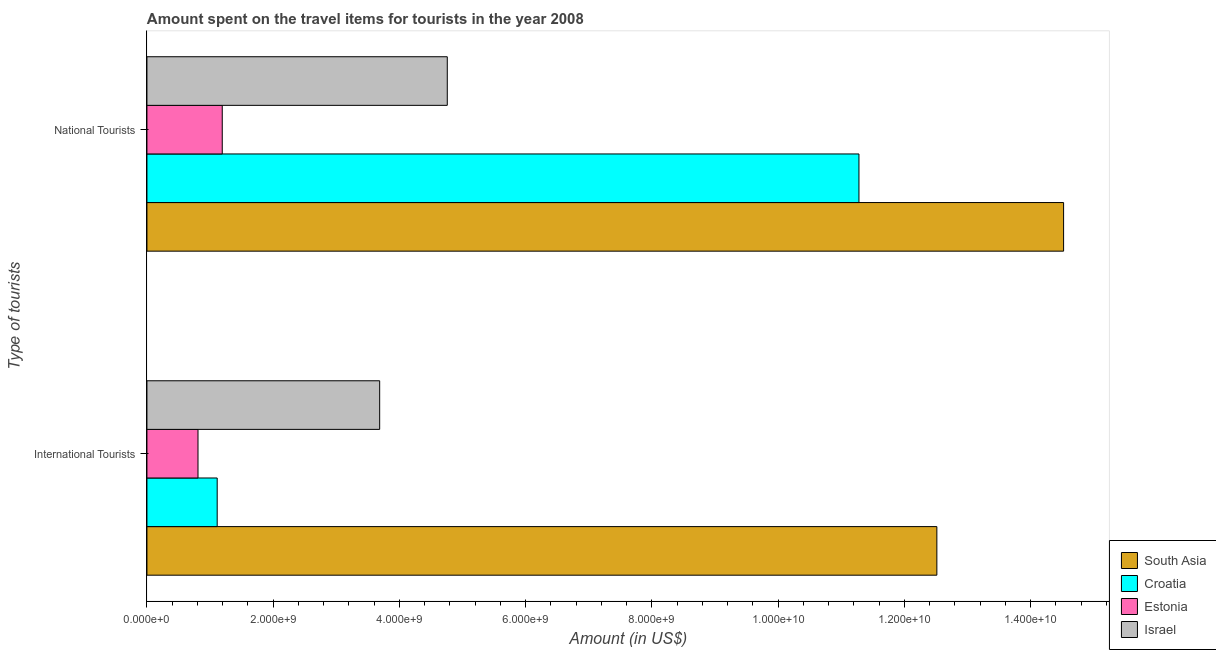How many groups of bars are there?
Provide a succinct answer. 2. How many bars are there on the 1st tick from the top?
Offer a terse response. 4. What is the label of the 1st group of bars from the top?
Offer a very short reply. National Tourists. What is the amount spent on travel items of national tourists in South Asia?
Ensure brevity in your answer.  1.45e+1. Across all countries, what is the maximum amount spent on travel items of national tourists?
Provide a short and direct response. 1.45e+1. Across all countries, what is the minimum amount spent on travel items of national tourists?
Your response must be concise. 1.19e+09. In which country was the amount spent on travel items of international tourists maximum?
Keep it short and to the point. South Asia. In which country was the amount spent on travel items of international tourists minimum?
Provide a short and direct response. Estonia. What is the total amount spent on travel items of international tourists in the graph?
Your answer should be very brief. 1.81e+1. What is the difference between the amount spent on travel items of international tourists in Croatia and that in South Asia?
Provide a succinct answer. -1.14e+1. What is the difference between the amount spent on travel items of international tourists in Israel and the amount spent on travel items of national tourists in Croatia?
Your response must be concise. -7.59e+09. What is the average amount spent on travel items of national tourists per country?
Your answer should be compact. 7.94e+09. What is the difference between the amount spent on travel items of national tourists and amount spent on travel items of international tourists in Israel?
Your response must be concise. 1.07e+09. What is the ratio of the amount spent on travel items of international tourists in South Asia to that in Croatia?
Offer a terse response. 11.24. Is the amount spent on travel items of national tourists in Israel less than that in Estonia?
Keep it short and to the point. No. What does the 4th bar from the top in International Tourists represents?
Provide a short and direct response. South Asia. What does the 2nd bar from the bottom in National Tourists represents?
Offer a terse response. Croatia. Are all the bars in the graph horizontal?
Ensure brevity in your answer.  Yes. How many countries are there in the graph?
Keep it short and to the point. 4. What is the difference between two consecutive major ticks on the X-axis?
Provide a succinct answer. 2.00e+09. Are the values on the major ticks of X-axis written in scientific E-notation?
Your answer should be very brief. Yes. Does the graph contain any zero values?
Give a very brief answer. No. Does the graph contain grids?
Provide a succinct answer. No. Where does the legend appear in the graph?
Offer a very short reply. Bottom right. What is the title of the graph?
Ensure brevity in your answer.  Amount spent on the travel items for tourists in the year 2008. What is the label or title of the Y-axis?
Make the answer very short. Type of tourists. What is the Amount (in US$) in South Asia in International Tourists?
Offer a terse response. 1.25e+1. What is the Amount (in US$) of Croatia in International Tourists?
Your response must be concise. 1.11e+09. What is the Amount (in US$) in Estonia in International Tourists?
Ensure brevity in your answer.  8.09e+08. What is the Amount (in US$) of Israel in International Tourists?
Offer a very short reply. 3.69e+09. What is the Amount (in US$) in South Asia in National Tourists?
Give a very brief answer. 1.45e+1. What is the Amount (in US$) of Croatia in National Tourists?
Keep it short and to the point. 1.13e+1. What is the Amount (in US$) of Estonia in National Tourists?
Offer a terse response. 1.19e+09. What is the Amount (in US$) of Israel in National Tourists?
Keep it short and to the point. 4.76e+09. Across all Type of tourists, what is the maximum Amount (in US$) of South Asia?
Provide a short and direct response. 1.45e+1. Across all Type of tourists, what is the maximum Amount (in US$) in Croatia?
Your answer should be very brief. 1.13e+1. Across all Type of tourists, what is the maximum Amount (in US$) in Estonia?
Your answer should be very brief. 1.19e+09. Across all Type of tourists, what is the maximum Amount (in US$) of Israel?
Your answer should be very brief. 4.76e+09. Across all Type of tourists, what is the minimum Amount (in US$) of South Asia?
Keep it short and to the point. 1.25e+1. Across all Type of tourists, what is the minimum Amount (in US$) in Croatia?
Offer a very short reply. 1.11e+09. Across all Type of tourists, what is the minimum Amount (in US$) of Estonia?
Your response must be concise. 8.09e+08. Across all Type of tourists, what is the minimum Amount (in US$) of Israel?
Give a very brief answer. 3.69e+09. What is the total Amount (in US$) of South Asia in the graph?
Make the answer very short. 2.70e+1. What is the total Amount (in US$) of Croatia in the graph?
Ensure brevity in your answer.  1.24e+1. What is the total Amount (in US$) in Estonia in the graph?
Make the answer very short. 2.00e+09. What is the total Amount (in US$) of Israel in the graph?
Your answer should be very brief. 8.44e+09. What is the difference between the Amount (in US$) in South Asia in International Tourists and that in National Tourists?
Offer a terse response. -2.01e+09. What is the difference between the Amount (in US$) of Croatia in International Tourists and that in National Tourists?
Provide a short and direct response. -1.02e+1. What is the difference between the Amount (in US$) of Estonia in International Tourists and that in National Tourists?
Offer a very short reply. -3.84e+08. What is the difference between the Amount (in US$) in Israel in International Tourists and that in National Tourists?
Offer a terse response. -1.07e+09. What is the difference between the Amount (in US$) in South Asia in International Tourists and the Amount (in US$) in Croatia in National Tourists?
Give a very brief answer. 1.23e+09. What is the difference between the Amount (in US$) of South Asia in International Tourists and the Amount (in US$) of Estonia in National Tourists?
Ensure brevity in your answer.  1.13e+1. What is the difference between the Amount (in US$) in South Asia in International Tourists and the Amount (in US$) in Israel in National Tourists?
Offer a terse response. 7.76e+09. What is the difference between the Amount (in US$) in Croatia in International Tourists and the Amount (in US$) in Estonia in National Tourists?
Provide a short and direct response. -8.00e+07. What is the difference between the Amount (in US$) in Croatia in International Tourists and the Amount (in US$) in Israel in National Tourists?
Provide a short and direct response. -3.64e+09. What is the difference between the Amount (in US$) of Estonia in International Tourists and the Amount (in US$) of Israel in National Tourists?
Offer a terse response. -3.95e+09. What is the average Amount (in US$) in South Asia per Type of tourists?
Your answer should be very brief. 1.35e+1. What is the average Amount (in US$) of Croatia per Type of tourists?
Offer a very short reply. 6.20e+09. What is the average Amount (in US$) in Estonia per Type of tourists?
Give a very brief answer. 1.00e+09. What is the average Amount (in US$) of Israel per Type of tourists?
Your answer should be compact. 4.22e+09. What is the difference between the Amount (in US$) in South Asia and Amount (in US$) in Croatia in International Tourists?
Provide a short and direct response. 1.14e+1. What is the difference between the Amount (in US$) of South Asia and Amount (in US$) of Estonia in International Tourists?
Make the answer very short. 1.17e+1. What is the difference between the Amount (in US$) of South Asia and Amount (in US$) of Israel in International Tourists?
Your response must be concise. 8.83e+09. What is the difference between the Amount (in US$) in Croatia and Amount (in US$) in Estonia in International Tourists?
Make the answer very short. 3.04e+08. What is the difference between the Amount (in US$) in Croatia and Amount (in US$) in Israel in International Tourists?
Make the answer very short. -2.57e+09. What is the difference between the Amount (in US$) of Estonia and Amount (in US$) of Israel in International Tourists?
Offer a terse response. -2.88e+09. What is the difference between the Amount (in US$) of South Asia and Amount (in US$) of Croatia in National Tourists?
Provide a succinct answer. 3.24e+09. What is the difference between the Amount (in US$) of South Asia and Amount (in US$) of Estonia in National Tourists?
Keep it short and to the point. 1.33e+1. What is the difference between the Amount (in US$) of South Asia and Amount (in US$) of Israel in National Tourists?
Provide a short and direct response. 9.76e+09. What is the difference between the Amount (in US$) of Croatia and Amount (in US$) of Estonia in National Tourists?
Offer a very short reply. 1.01e+1. What is the difference between the Amount (in US$) of Croatia and Amount (in US$) of Israel in National Tourists?
Offer a terse response. 6.52e+09. What is the difference between the Amount (in US$) in Estonia and Amount (in US$) in Israel in National Tourists?
Provide a succinct answer. -3.56e+09. What is the ratio of the Amount (in US$) of South Asia in International Tourists to that in National Tourists?
Make the answer very short. 0.86. What is the ratio of the Amount (in US$) in Croatia in International Tourists to that in National Tourists?
Offer a very short reply. 0.1. What is the ratio of the Amount (in US$) in Estonia in International Tourists to that in National Tourists?
Offer a very short reply. 0.68. What is the ratio of the Amount (in US$) of Israel in International Tourists to that in National Tourists?
Provide a short and direct response. 0.77. What is the difference between the highest and the second highest Amount (in US$) in South Asia?
Offer a very short reply. 2.01e+09. What is the difference between the highest and the second highest Amount (in US$) of Croatia?
Offer a very short reply. 1.02e+1. What is the difference between the highest and the second highest Amount (in US$) of Estonia?
Make the answer very short. 3.84e+08. What is the difference between the highest and the second highest Amount (in US$) in Israel?
Make the answer very short. 1.07e+09. What is the difference between the highest and the lowest Amount (in US$) of South Asia?
Make the answer very short. 2.01e+09. What is the difference between the highest and the lowest Amount (in US$) in Croatia?
Your response must be concise. 1.02e+1. What is the difference between the highest and the lowest Amount (in US$) in Estonia?
Provide a short and direct response. 3.84e+08. What is the difference between the highest and the lowest Amount (in US$) in Israel?
Your answer should be compact. 1.07e+09. 